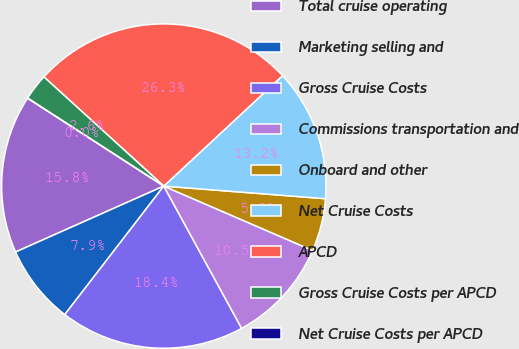<chart> <loc_0><loc_0><loc_500><loc_500><pie_chart><fcel>Total cruise operating<fcel>Marketing selling and<fcel>Gross Cruise Costs<fcel>Commissions transportation and<fcel>Onboard and other<fcel>Net Cruise Costs<fcel>APCD<fcel>Gross Cruise Costs per APCD<fcel>Net Cruise Costs per APCD<nl><fcel>15.79%<fcel>7.89%<fcel>18.42%<fcel>10.53%<fcel>5.26%<fcel>13.16%<fcel>26.32%<fcel>2.63%<fcel>0.0%<nl></chart> 